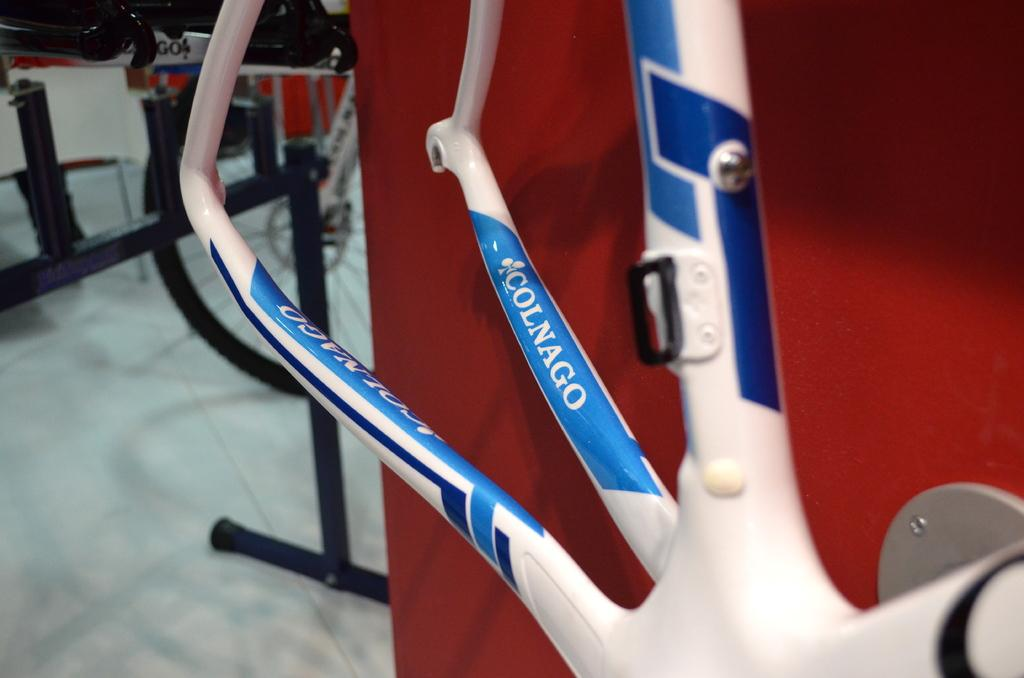What is the main object in the image? There is a metal rod with text in the image. What is the color of the background behind the text? The metal rod has a red color background. What other object can be seen on the floor in the image? There is a wheel on the floor in the image. What type of thread is being used to hold the wing in the image? There is no thread or wing present in the image. How many cellars can be seen in the image? There are no cellars visible in the image. 